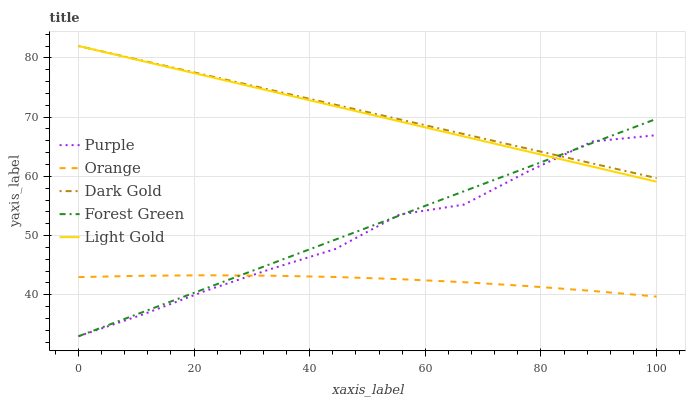Does Orange have the minimum area under the curve?
Answer yes or no. Yes. Does Dark Gold have the maximum area under the curve?
Answer yes or no. Yes. Does Forest Green have the minimum area under the curve?
Answer yes or no. No. Does Forest Green have the maximum area under the curve?
Answer yes or no. No. Is Forest Green the smoothest?
Answer yes or no. Yes. Is Purple the roughest?
Answer yes or no. Yes. Is Orange the smoothest?
Answer yes or no. No. Is Orange the roughest?
Answer yes or no. No. Does Purple have the lowest value?
Answer yes or no. Yes. Does Orange have the lowest value?
Answer yes or no. No. Does Dark Gold have the highest value?
Answer yes or no. Yes. Does Forest Green have the highest value?
Answer yes or no. No. Is Orange less than Light Gold?
Answer yes or no. Yes. Is Dark Gold greater than Orange?
Answer yes or no. Yes. Does Dark Gold intersect Light Gold?
Answer yes or no. Yes. Is Dark Gold less than Light Gold?
Answer yes or no. No. Is Dark Gold greater than Light Gold?
Answer yes or no. No. Does Orange intersect Light Gold?
Answer yes or no. No. 